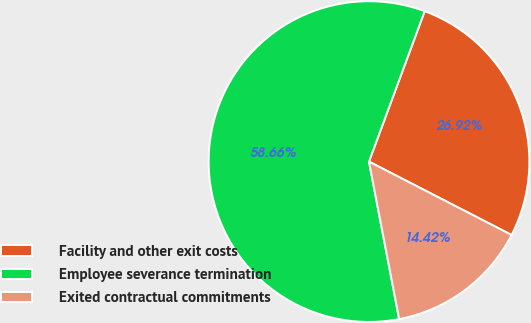Convert chart to OTSL. <chart><loc_0><loc_0><loc_500><loc_500><pie_chart><fcel>Facility and other exit costs<fcel>Employee severance termination<fcel>Exited contractual commitments<nl><fcel>26.92%<fcel>58.65%<fcel>14.42%<nl></chart> 